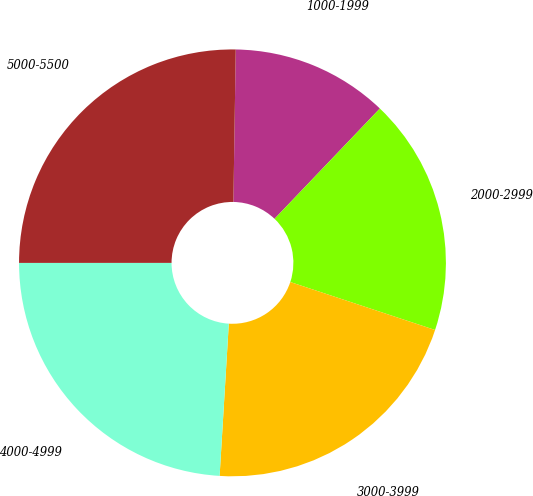Convert chart to OTSL. <chart><loc_0><loc_0><loc_500><loc_500><pie_chart><fcel>1000-1999<fcel>2000-2999<fcel>3000-3999<fcel>4000-4999<fcel>5000-5500<nl><fcel>11.89%<fcel>17.96%<fcel>20.87%<fcel>24.04%<fcel>25.25%<nl></chart> 